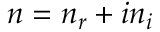<formula> <loc_0><loc_0><loc_500><loc_500>n = n _ { r } + i n _ { i }</formula> 